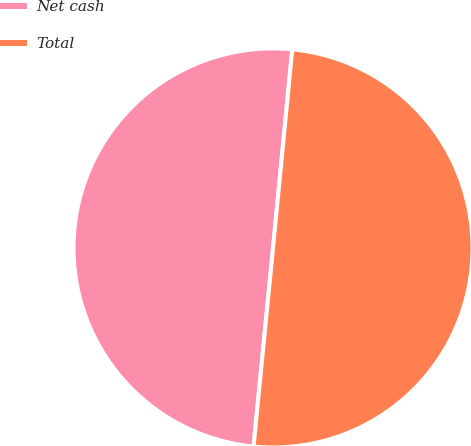Convert chart. <chart><loc_0><loc_0><loc_500><loc_500><pie_chart><fcel>Net cash<fcel>Total<nl><fcel>49.98%<fcel>50.02%<nl></chart> 